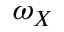Convert formula to latex. <formula><loc_0><loc_0><loc_500><loc_500>\omega _ { X }</formula> 